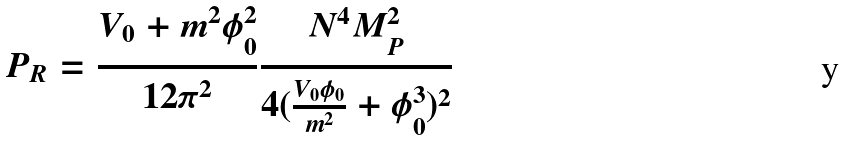Convert formula to latex. <formula><loc_0><loc_0><loc_500><loc_500>P _ { R } = \frac { V _ { 0 } + m ^ { 2 } \phi ^ { 2 } _ { 0 } } { 1 2 \pi ^ { 2 } } \frac { N ^ { 4 } M _ { P } ^ { 2 } } { 4 ( \frac { V _ { 0 } \phi _ { 0 } } { m ^ { 2 } } + \phi _ { 0 } ^ { 3 } ) ^ { 2 } }</formula> 